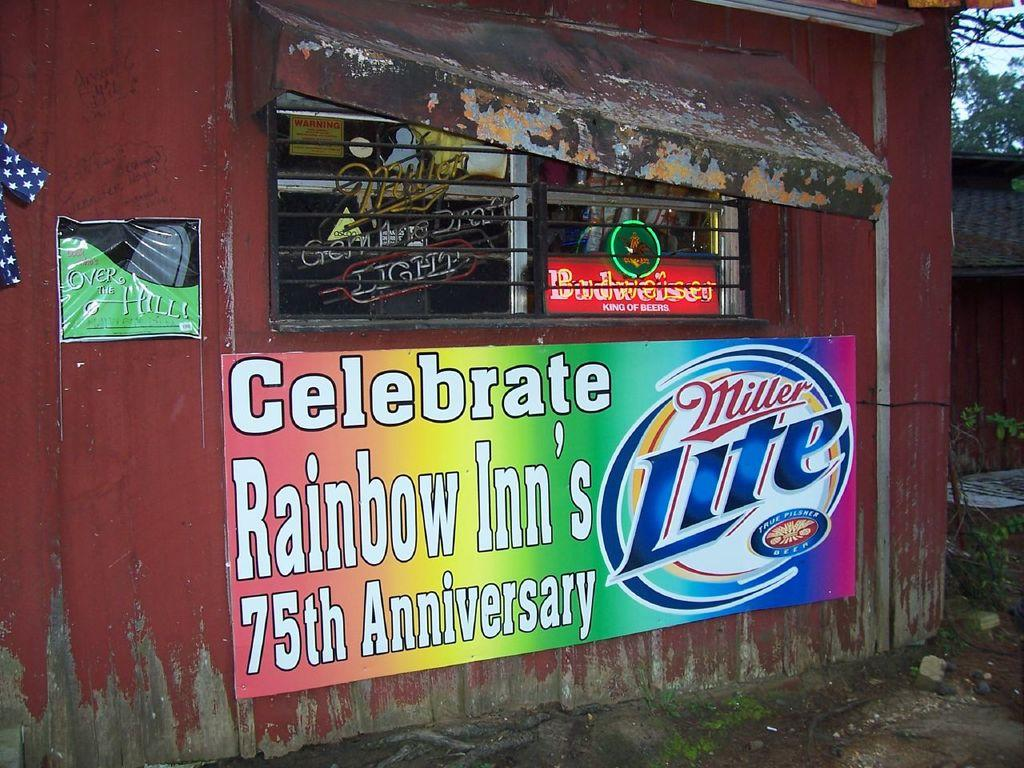<image>
Provide a brief description of the given image. The Rainbow Inn is celebrating its 75th anniversary. 